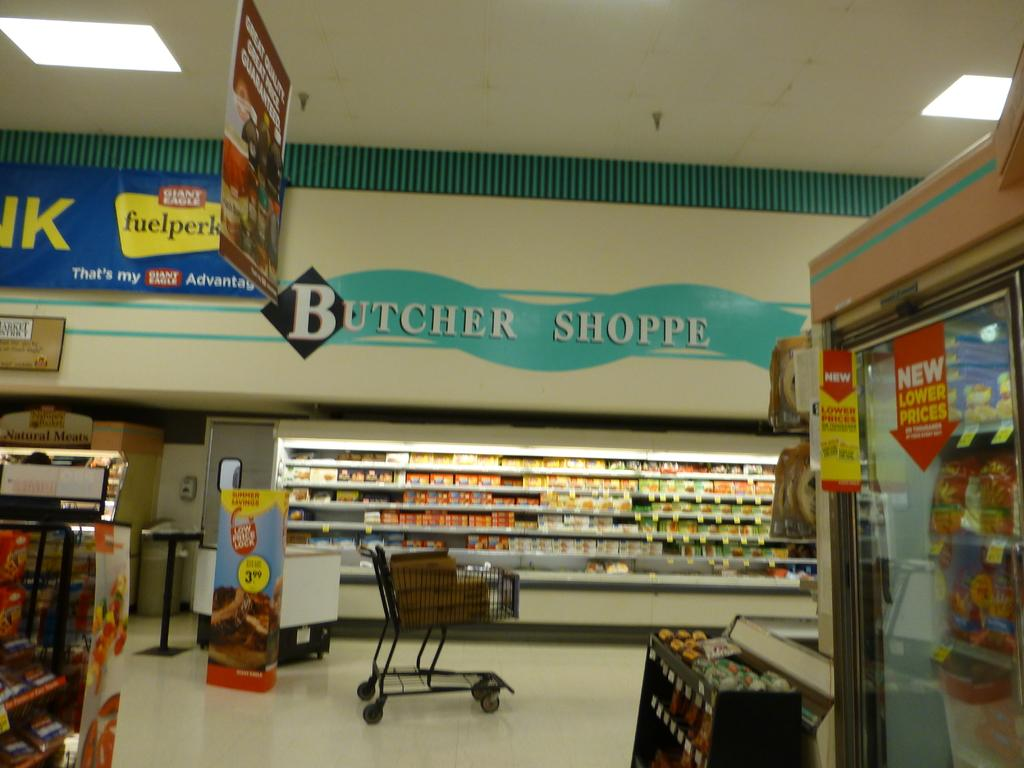<image>
Relay a brief, clear account of the picture shown. Butcher Shoppe logo in a store above the buggy. 